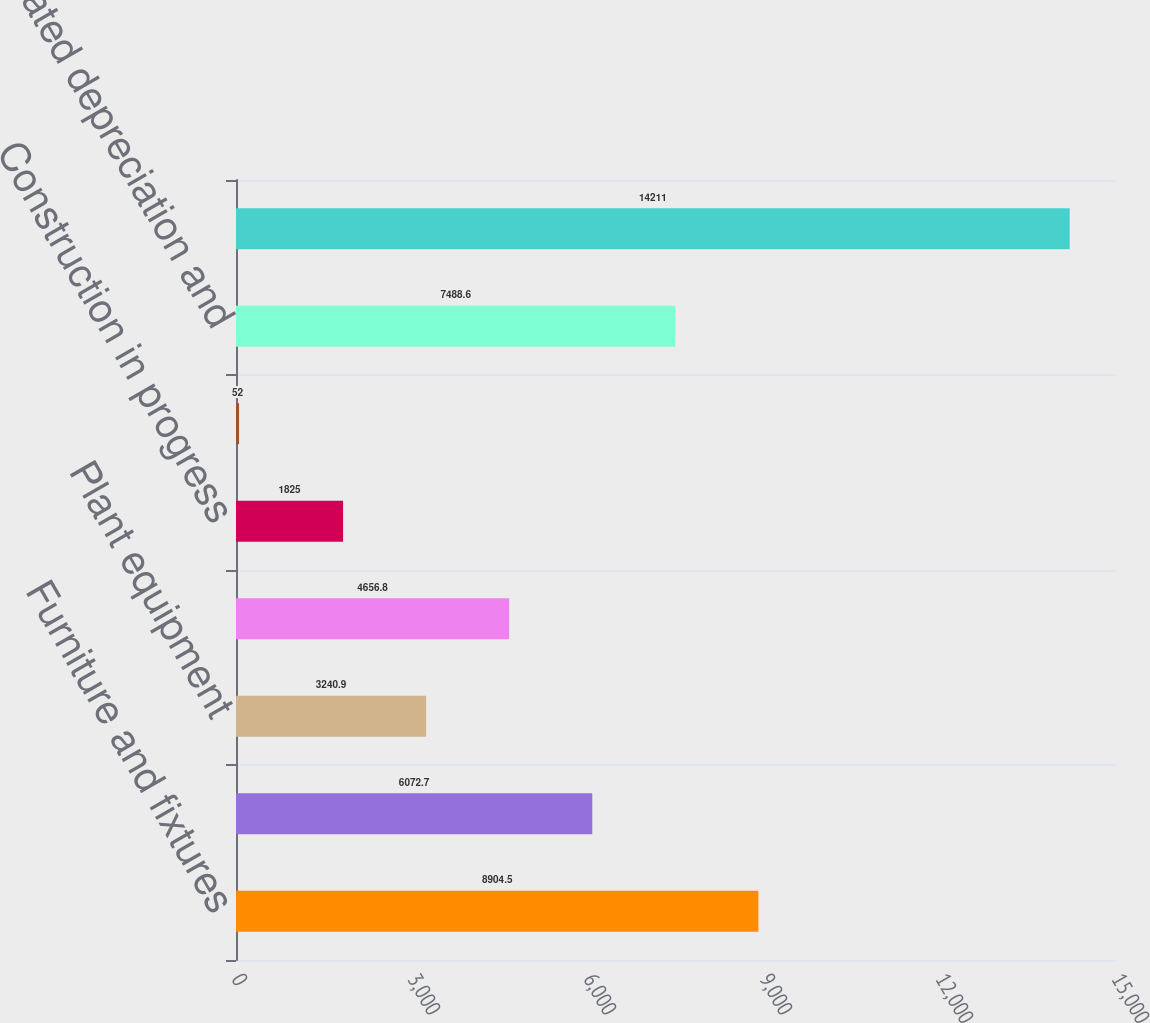Convert chart to OTSL. <chart><loc_0><loc_0><loc_500><loc_500><bar_chart><fcel>Furniture and fixtures<fcel>Office equipment and software<fcel>Plant equipment<fcel>Leasehold improvements<fcel>Construction in progress<fcel>Other<fcel>Accumulated depreciation and<fcel>Property and equipment net<nl><fcel>8904.5<fcel>6072.7<fcel>3240.9<fcel>4656.8<fcel>1825<fcel>52<fcel>7488.6<fcel>14211<nl></chart> 